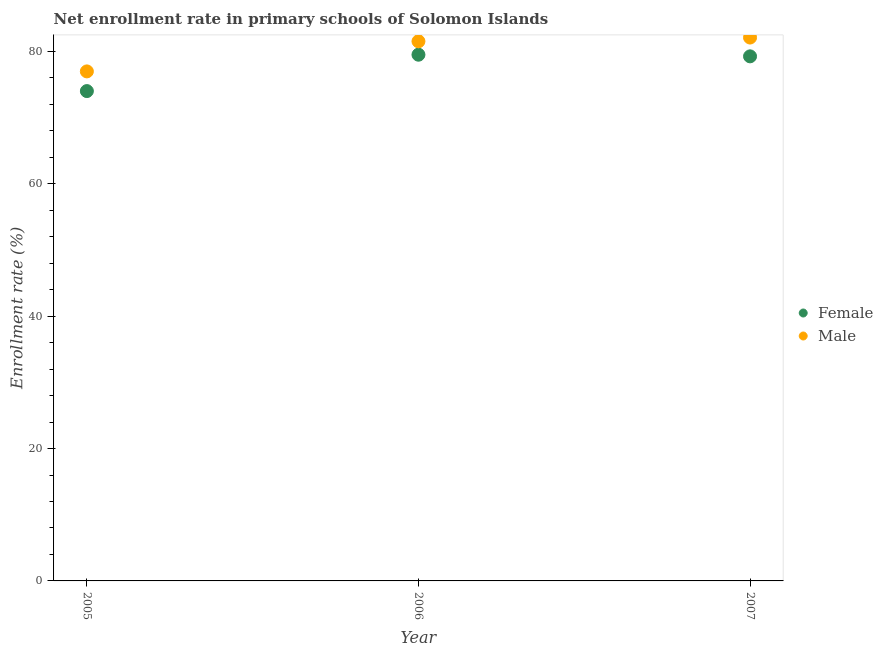How many different coloured dotlines are there?
Provide a succinct answer. 2. What is the enrollment rate of male students in 2006?
Your answer should be very brief. 81.54. Across all years, what is the maximum enrollment rate of female students?
Your answer should be very brief. 79.52. Across all years, what is the minimum enrollment rate of male students?
Your answer should be very brief. 77. In which year was the enrollment rate of female students minimum?
Your answer should be very brief. 2005. What is the total enrollment rate of male students in the graph?
Your response must be concise. 240.65. What is the difference between the enrollment rate of male students in 2005 and that in 2006?
Your answer should be very brief. -4.55. What is the difference between the enrollment rate of male students in 2006 and the enrollment rate of female students in 2005?
Give a very brief answer. 7.52. What is the average enrollment rate of female students per year?
Ensure brevity in your answer.  77.6. In the year 2007, what is the difference between the enrollment rate of female students and enrollment rate of male students?
Keep it short and to the point. -2.84. In how many years, is the enrollment rate of female students greater than 52 %?
Offer a very short reply. 3. What is the ratio of the enrollment rate of female students in 2005 to that in 2007?
Make the answer very short. 0.93. Is the enrollment rate of female students in 2005 less than that in 2007?
Your response must be concise. Yes. Is the difference between the enrollment rate of female students in 2006 and 2007 greater than the difference between the enrollment rate of male students in 2006 and 2007?
Your response must be concise. Yes. What is the difference between the highest and the second highest enrollment rate of male students?
Your answer should be compact. 0.57. What is the difference between the highest and the lowest enrollment rate of male students?
Your answer should be very brief. 5.11. In how many years, is the enrollment rate of male students greater than the average enrollment rate of male students taken over all years?
Offer a very short reply. 2. Does the enrollment rate of female students monotonically increase over the years?
Your answer should be very brief. No. How many dotlines are there?
Ensure brevity in your answer.  2. Are the values on the major ticks of Y-axis written in scientific E-notation?
Provide a short and direct response. No. Does the graph contain any zero values?
Make the answer very short. No. Does the graph contain grids?
Offer a very short reply. No. How many legend labels are there?
Keep it short and to the point. 2. What is the title of the graph?
Keep it short and to the point. Net enrollment rate in primary schools of Solomon Islands. What is the label or title of the Y-axis?
Offer a terse response. Enrollment rate (%). What is the Enrollment rate (%) of Female in 2005?
Your answer should be compact. 74.02. What is the Enrollment rate (%) in Male in 2005?
Ensure brevity in your answer.  77. What is the Enrollment rate (%) in Female in 2006?
Provide a succinct answer. 79.52. What is the Enrollment rate (%) in Male in 2006?
Provide a short and direct response. 81.54. What is the Enrollment rate (%) in Female in 2007?
Offer a very short reply. 79.27. What is the Enrollment rate (%) in Male in 2007?
Offer a very short reply. 82.11. Across all years, what is the maximum Enrollment rate (%) in Female?
Your answer should be very brief. 79.52. Across all years, what is the maximum Enrollment rate (%) of Male?
Provide a succinct answer. 82.11. Across all years, what is the minimum Enrollment rate (%) of Female?
Make the answer very short. 74.02. Across all years, what is the minimum Enrollment rate (%) of Male?
Keep it short and to the point. 77. What is the total Enrollment rate (%) in Female in the graph?
Your answer should be very brief. 232.81. What is the total Enrollment rate (%) of Male in the graph?
Offer a very short reply. 240.65. What is the difference between the Enrollment rate (%) in Female in 2005 and that in 2006?
Provide a succinct answer. -5.5. What is the difference between the Enrollment rate (%) of Male in 2005 and that in 2006?
Ensure brevity in your answer.  -4.55. What is the difference between the Enrollment rate (%) in Female in 2005 and that in 2007?
Ensure brevity in your answer.  -5.25. What is the difference between the Enrollment rate (%) of Male in 2005 and that in 2007?
Your answer should be compact. -5.11. What is the difference between the Enrollment rate (%) in Female in 2006 and that in 2007?
Make the answer very short. 0.25. What is the difference between the Enrollment rate (%) of Male in 2006 and that in 2007?
Give a very brief answer. -0.57. What is the difference between the Enrollment rate (%) in Female in 2005 and the Enrollment rate (%) in Male in 2006?
Keep it short and to the point. -7.52. What is the difference between the Enrollment rate (%) of Female in 2005 and the Enrollment rate (%) of Male in 2007?
Ensure brevity in your answer.  -8.09. What is the difference between the Enrollment rate (%) of Female in 2006 and the Enrollment rate (%) of Male in 2007?
Your answer should be compact. -2.59. What is the average Enrollment rate (%) of Female per year?
Your answer should be compact. 77.6. What is the average Enrollment rate (%) in Male per year?
Provide a short and direct response. 80.22. In the year 2005, what is the difference between the Enrollment rate (%) in Female and Enrollment rate (%) in Male?
Provide a short and direct response. -2.98. In the year 2006, what is the difference between the Enrollment rate (%) in Female and Enrollment rate (%) in Male?
Make the answer very short. -2.03. In the year 2007, what is the difference between the Enrollment rate (%) in Female and Enrollment rate (%) in Male?
Offer a terse response. -2.84. What is the ratio of the Enrollment rate (%) of Female in 2005 to that in 2006?
Your response must be concise. 0.93. What is the ratio of the Enrollment rate (%) of Male in 2005 to that in 2006?
Offer a very short reply. 0.94. What is the ratio of the Enrollment rate (%) of Female in 2005 to that in 2007?
Provide a short and direct response. 0.93. What is the ratio of the Enrollment rate (%) of Male in 2005 to that in 2007?
Keep it short and to the point. 0.94. What is the ratio of the Enrollment rate (%) in Female in 2006 to that in 2007?
Provide a succinct answer. 1. What is the difference between the highest and the second highest Enrollment rate (%) in Female?
Ensure brevity in your answer.  0.25. What is the difference between the highest and the second highest Enrollment rate (%) in Male?
Provide a succinct answer. 0.57. What is the difference between the highest and the lowest Enrollment rate (%) of Female?
Your response must be concise. 5.5. What is the difference between the highest and the lowest Enrollment rate (%) of Male?
Provide a short and direct response. 5.11. 